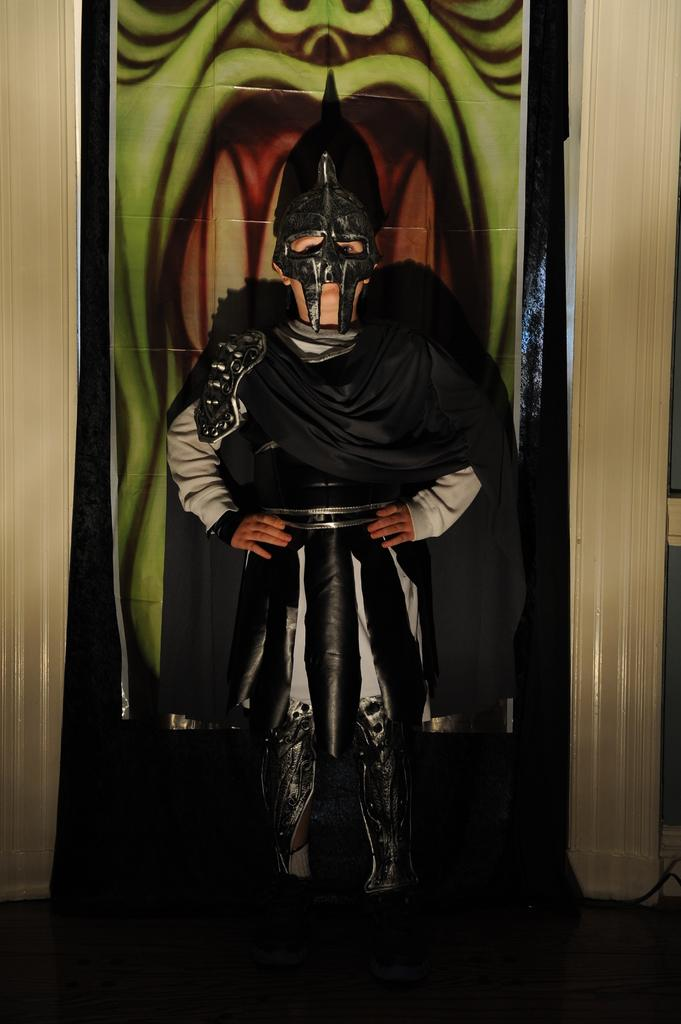What can be seen in the image related to a person? There is a person in the image. What is the person wearing on their face? The person is wearing a mask. What else is the person wearing? The person is wearing a costume. What can be seen in the background of the image? There is a poster and pillars in the background of the image. Can you hear the spiders whistling in the image? There are no spiders or whistling sounds present in the image. 